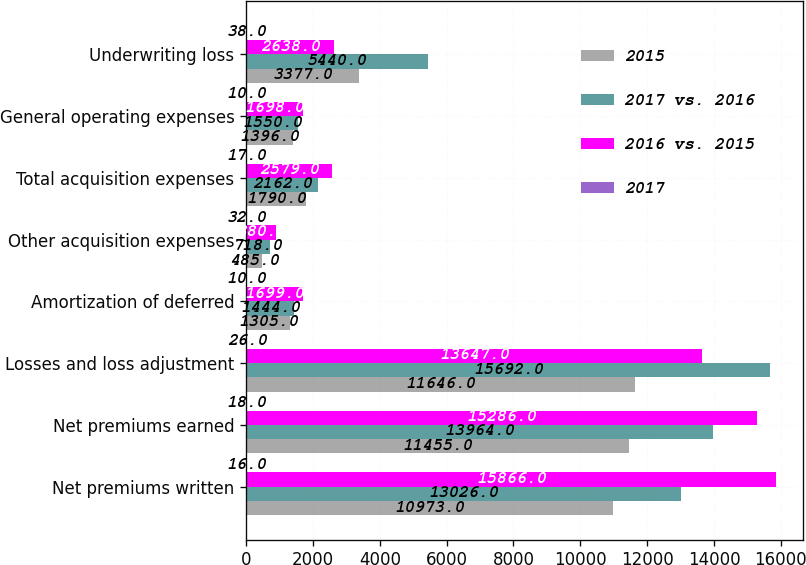<chart> <loc_0><loc_0><loc_500><loc_500><stacked_bar_chart><ecel><fcel>Net premiums written<fcel>Net premiums earned<fcel>Losses and loss adjustment<fcel>Amortization of deferred<fcel>Other acquisition expenses<fcel>Total acquisition expenses<fcel>General operating expenses<fcel>Underwriting loss<nl><fcel>2015<fcel>10973<fcel>11455<fcel>11646<fcel>1305<fcel>485<fcel>1790<fcel>1396<fcel>3377<nl><fcel>2017 vs. 2016<fcel>13026<fcel>13964<fcel>15692<fcel>1444<fcel>718<fcel>2162<fcel>1550<fcel>5440<nl><fcel>2016 vs. 2015<fcel>15866<fcel>15286<fcel>13647<fcel>1699<fcel>880<fcel>2579<fcel>1698<fcel>2638<nl><fcel>2017<fcel>16<fcel>18<fcel>26<fcel>10<fcel>32<fcel>17<fcel>10<fcel>38<nl></chart> 